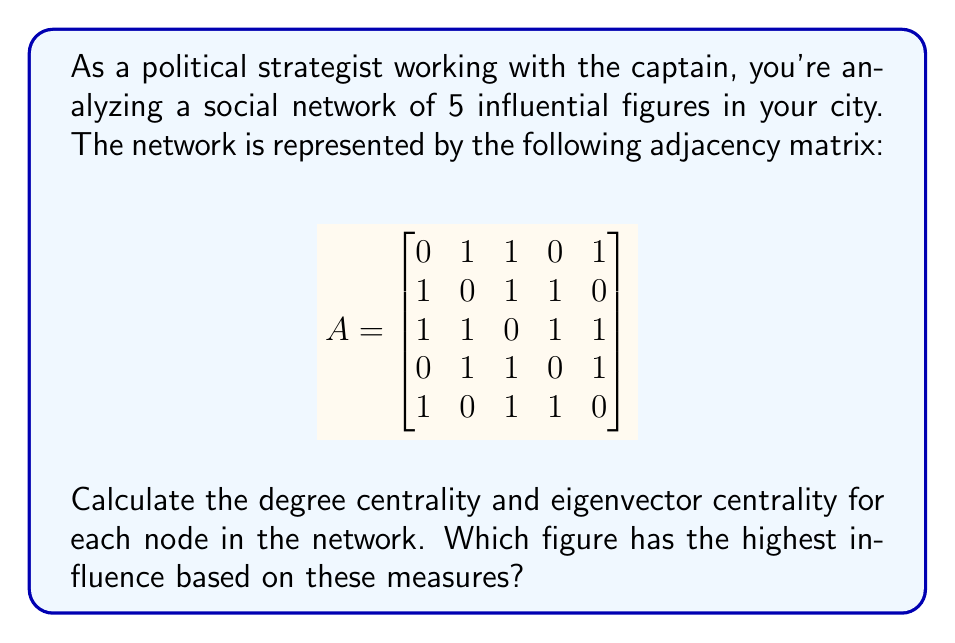What is the answer to this math problem? To solve this problem, we'll calculate both degree centrality and eigenvector centrality for each node in the network.

1. Degree Centrality:
Degree centrality is the number of direct connections a node has. For an undirected graph, it's the sum of each row (or column) in the adjacency matrix.

Node 1: $1 + 1 + 0 + 1 = 3$
Node 2: $1 + 1 + 1 + 0 = 3$
Node 3: $1 + 1 + 1 + 1 = 4$
Node 4: $0 + 1 + 1 + 1 = 3$
Node 5: $1 + 0 + 1 + 1 = 3$

2. Eigenvector Centrality:
Eigenvector centrality is calculated using the dominant eigenvector of the adjacency matrix. We'll use the power iteration method to approximate it.

Starting with an initial vector $x_0 = [1, 1, 1, 1, 1]^T$, we iterate:

$$x_{k+1} = \frac{Ax_k}{||Ax_k||}$$

After several iterations, we get the approximate eigenvector:

$$x \approx [0.4472, 0.4472, 0.5477, 0.4472, 0.4472]^T$$

This gives us the relative eigenvector centrality scores for each node.

Comparing the results:

1. Degree Centrality: Node 3 has the highest score (4)
2. Eigenvector Centrality: Node 3 has the highest score (0.5477)

Both measures indicate that Node 3 has the highest influence in the network.
Answer: Node 3 has the highest influence based on both degree centrality (4) and eigenvector centrality (0.5477). 